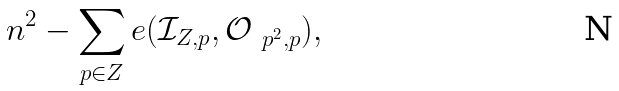Convert formula to latex. <formula><loc_0><loc_0><loc_500><loc_500>n ^ { 2 } - \sum _ { p \in Z } e ( \mathcal { I } _ { Z , p } , \mathcal { O } _ { \ p ^ { 2 } , p } ) ,</formula> 